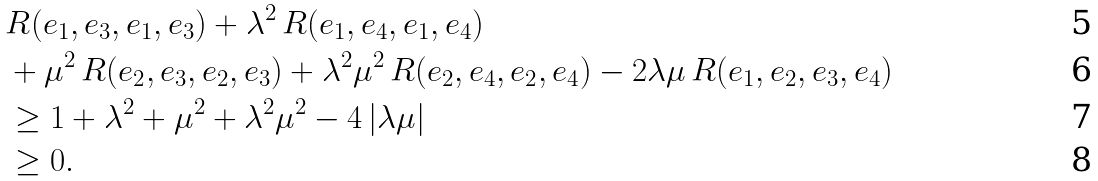<formula> <loc_0><loc_0><loc_500><loc_500>& R ( e _ { 1 } , e _ { 3 } , e _ { 1 } , e _ { 3 } ) + \lambda ^ { 2 } \, R ( e _ { 1 } , e _ { 4 } , e _ { 1 } , e _ { 4 } ) \\ & + \mu ^ { 2 } \, R ( e _ { 2 } , e _ { 3 } , e _ { 2 } , e _ { 3 } ) + \lambda ^ { 2 } \mu ^ { 2 } \, R ( e _ { 2 } , e _ { 4 } , e _ { 2 } , e _ { 4 } ) - 2 \lambda \mu \, R ( e _ { 1 } , e _ { 2 } , e _ { 3 } , e _ { 4 } ) \\ & \geq 1 + \lambda ^ { 2 } + \mu ^ { 2 } + \lambda ^ { 2 } \mu ^ { 2 } - 4 \, | \lambda \mu | \\ & \geq 0 .</formula> 